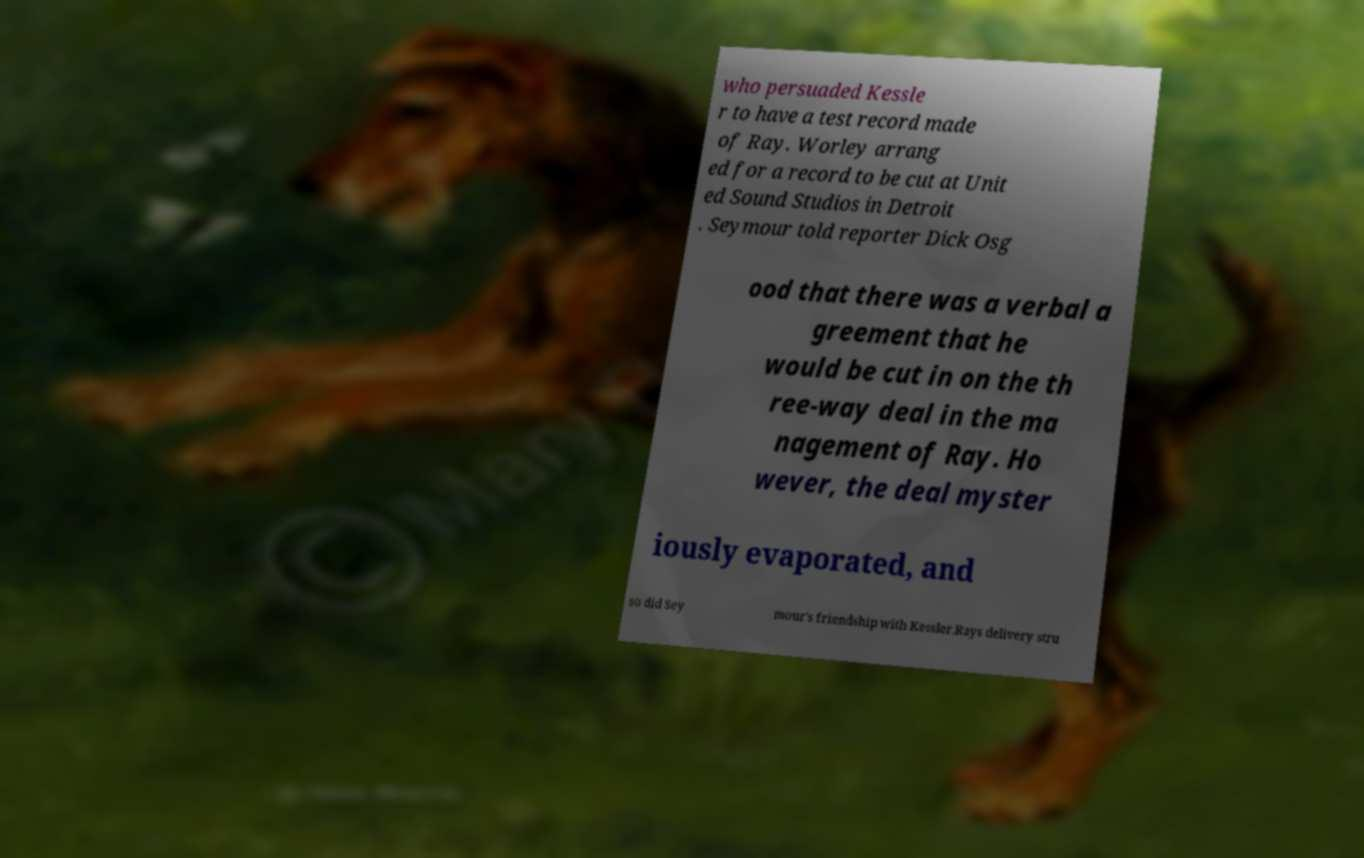Can you read and provide the text displayed in the image?This photo seems to have some interesting text. Can you extract and type it out for me? who persuaded Kessle r to have a test record made of Ray. Worley arrang ed for a record to be cut at Unit ed Sound Studios in Detroit . Seymour told reporter Dick Osg ood that there was a verbal a greement that he would be cut in on the th ree-way deal in the ma nagement of Ray. Ho wever, the deal myster iously evaporated, and so did Sey mour's friendship with Kessler.Rays delivery stru 